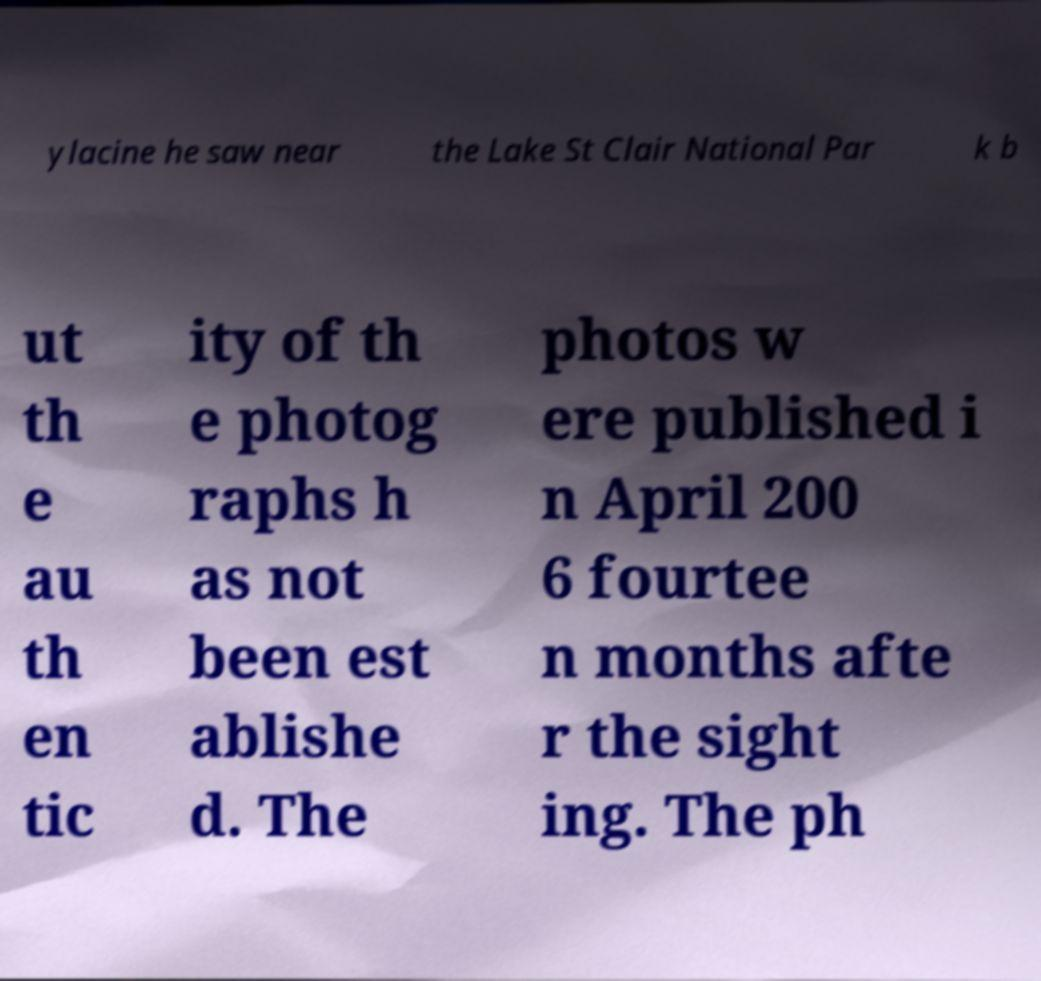Can you accurately transcribe the text from the provided image for me? ylacine he saw near the Lake St Clair National Par k b ut th e au th en tic ity of th e photog raphs h as not been est ablishe d. The photos w ere published i n April 200 6 fourtee n months afte r the sight ing. The ph 